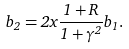Convert formula to latex. <formula><loc_0><loc_0><loc_500><loc_500>b _ { 2 } = 2 x \frac { 1 + R } { 1 + \gamma ^ { 2 } } b _ { 1 } .</formula> 